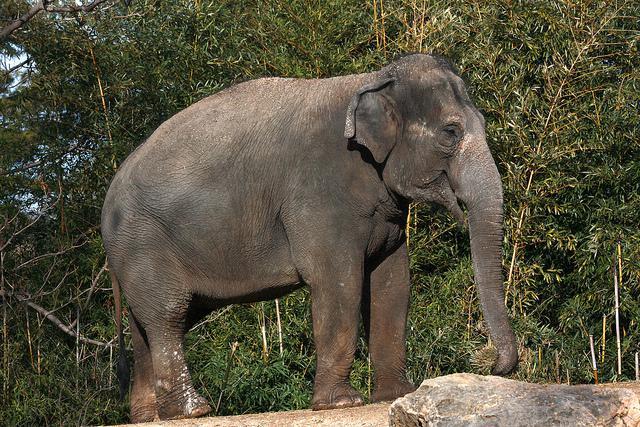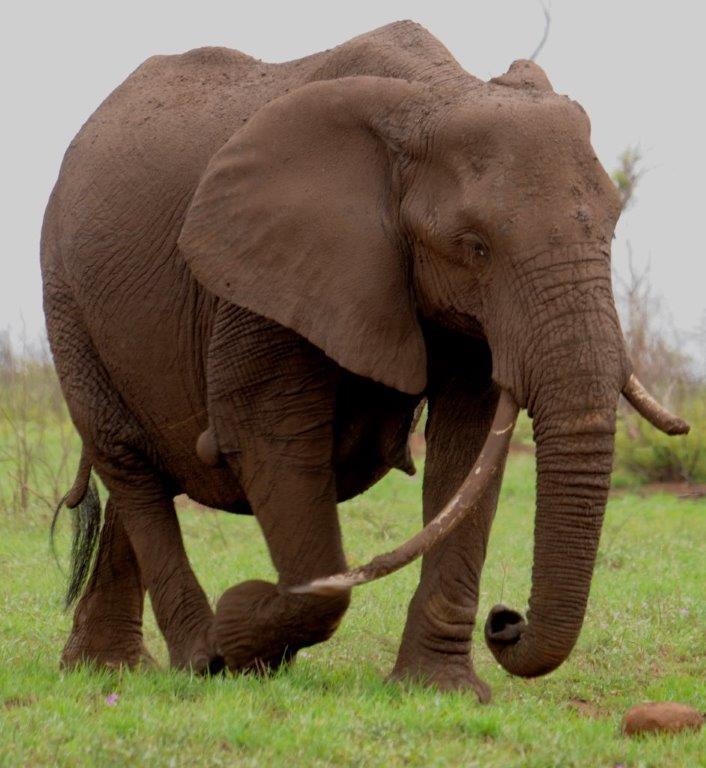The first image is the image on the left, the second image is the image on the right. For the images shown, is this caption "The left image includes an elephant with tusks, but the right image contains only a tuskless elephant." true? Answer yes or no. No. The first image is the image on the left, the second image is the image on the right. For the images shown, is this caption "The elephant in the right image is walking towards the right." true? Answer yes or no. Yes. 